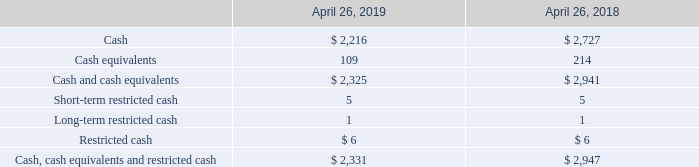6. Supplemental Financial Information
Cash and cash equivalents (in millions):
The following table presents cash and cash equivalents as reported in our consolidated balance sheets, as well as the sum of cash, cash equivalents and restricted cash as reported on our consolidated statement of cash flows in accordance with our adoption of the ASU discussed in Note 1 – Description of Business and Significant Accounting Policies.
Which years does the table provide information for cash and cash equivalents? 2019, 2018. What was the amount of cash in 2019?
Answer scale should be: million. 2,216. What was the amount of cash equivalents in 2018?
Answer scale should be: million. 214. What was the change in cash between 2018 and 2019?
Answer scale should be: million. 2,216-2,727
Answer: -511. What was the change in cash and cash equivalents between 2018 and 2019?
Answer scale should be: million. 2,325-2,941
Answer: -616. What was the percentage change in Cash, cash equivalents and restricted cash between 2018 and 2019?
Answer scale should be: percent. (2,331-2,947)/2,947
Answer: -20.9. 